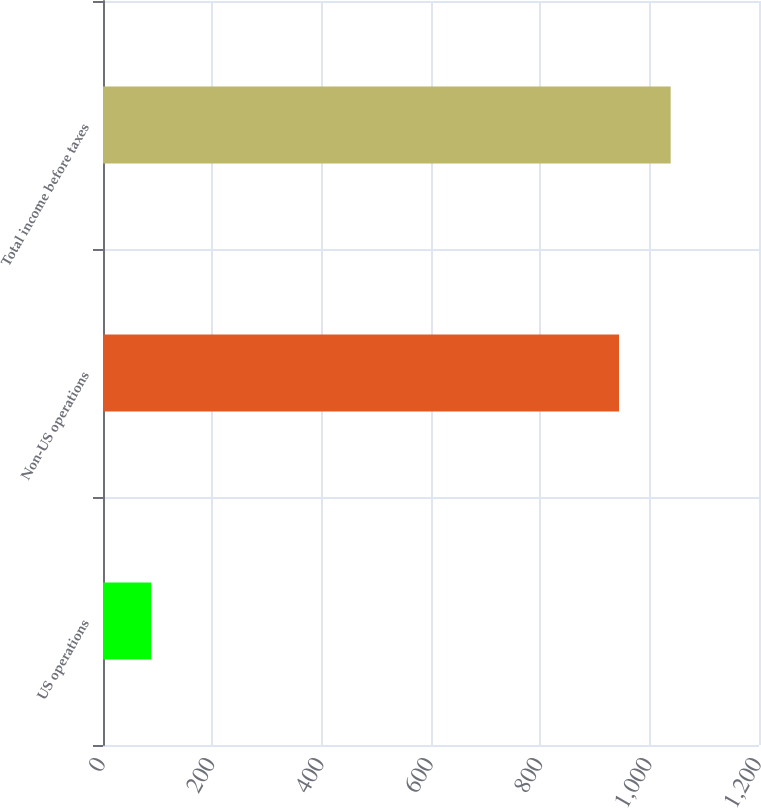<chart> <loc_0><loc_0><loc_500><loc_500><bar_chart><fcel>US operations<fcel>Non-US operations<fcel>Total income before taxes<nl><fcel>88<fcel>944<fcel>1038.4<nl></chart> 